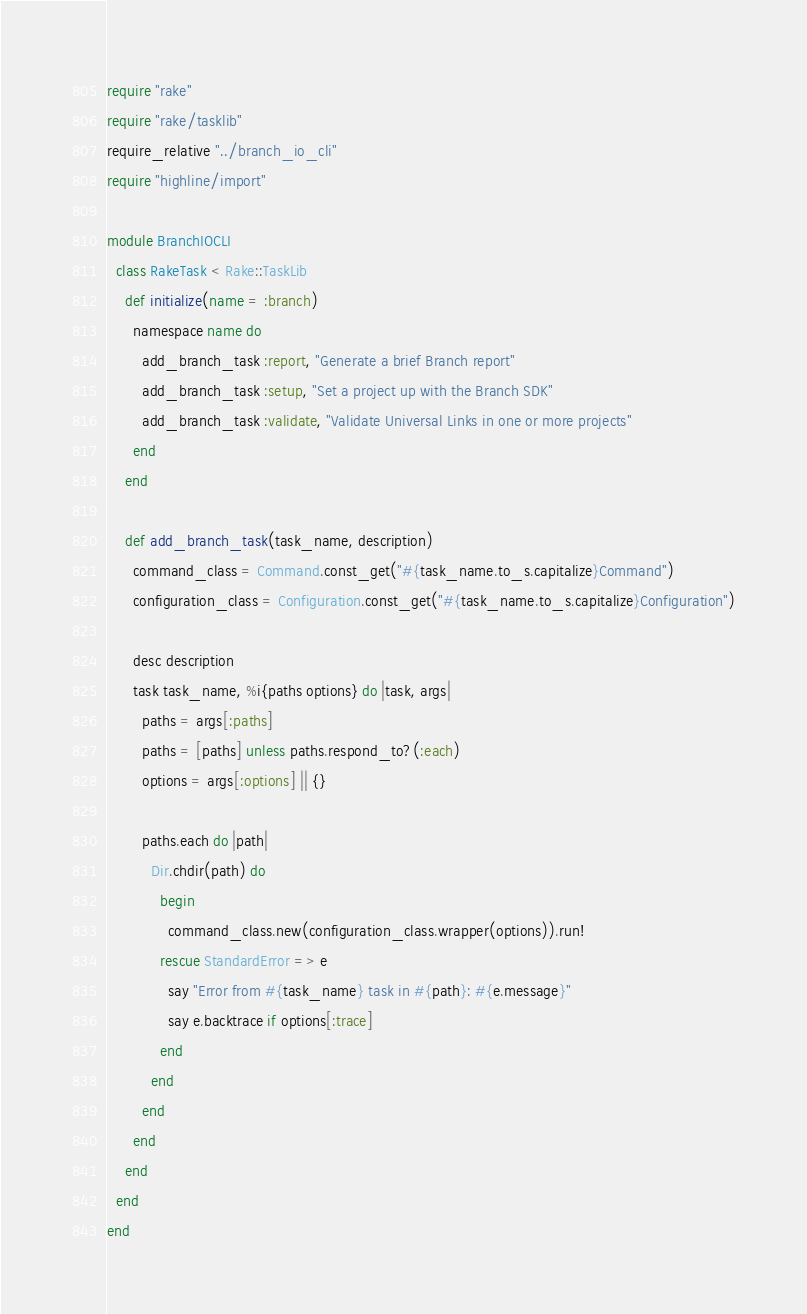Convert code to text. <code><loc_0><loc_0><loc_500><loc_500><_Ruby_>require "rake"
require "rake/tasklib"
require_relative "../branch_io_cli"
require "highline/import"

module BranchIOCLI
  class RakeTask < Rake::TaskLib
    def initialize(name = :branch)
      namespace name do
        add_branch_task :report, "Generate a brief Branch report"
        add_branch_task :setup, "Set a project up with the Branch SDK"
        add_branch_task :validate, "Validate Universal Links in one or more projects"
      end
    end

    def add_branch_task(task_name, description)
      command_class = Command.const_get("#{task_name.to_s.capitalize}Command")
      configuration_class = Configuration.const_get("#{task_name.to_s.capitalize}Configuration")

      desc description
      task task_name, %i{paths options} do |task, args|
        paths = args[:paths]
        paths = [paths] unless paths.respond_to?(:each)
        options = args[:options] || {}

        paths.each do |path|
          Dir.chdir(path) do
            begin
              command_class.new(configuration_class.wrapper(options)).run!
            rescue StandardError => e
              say "Error from #{task_name} task in #{path}: #{e.message}"
              say e.backtrace if options[:trace]
            end
          end
        end
      end
    end
  end
end
</code> 